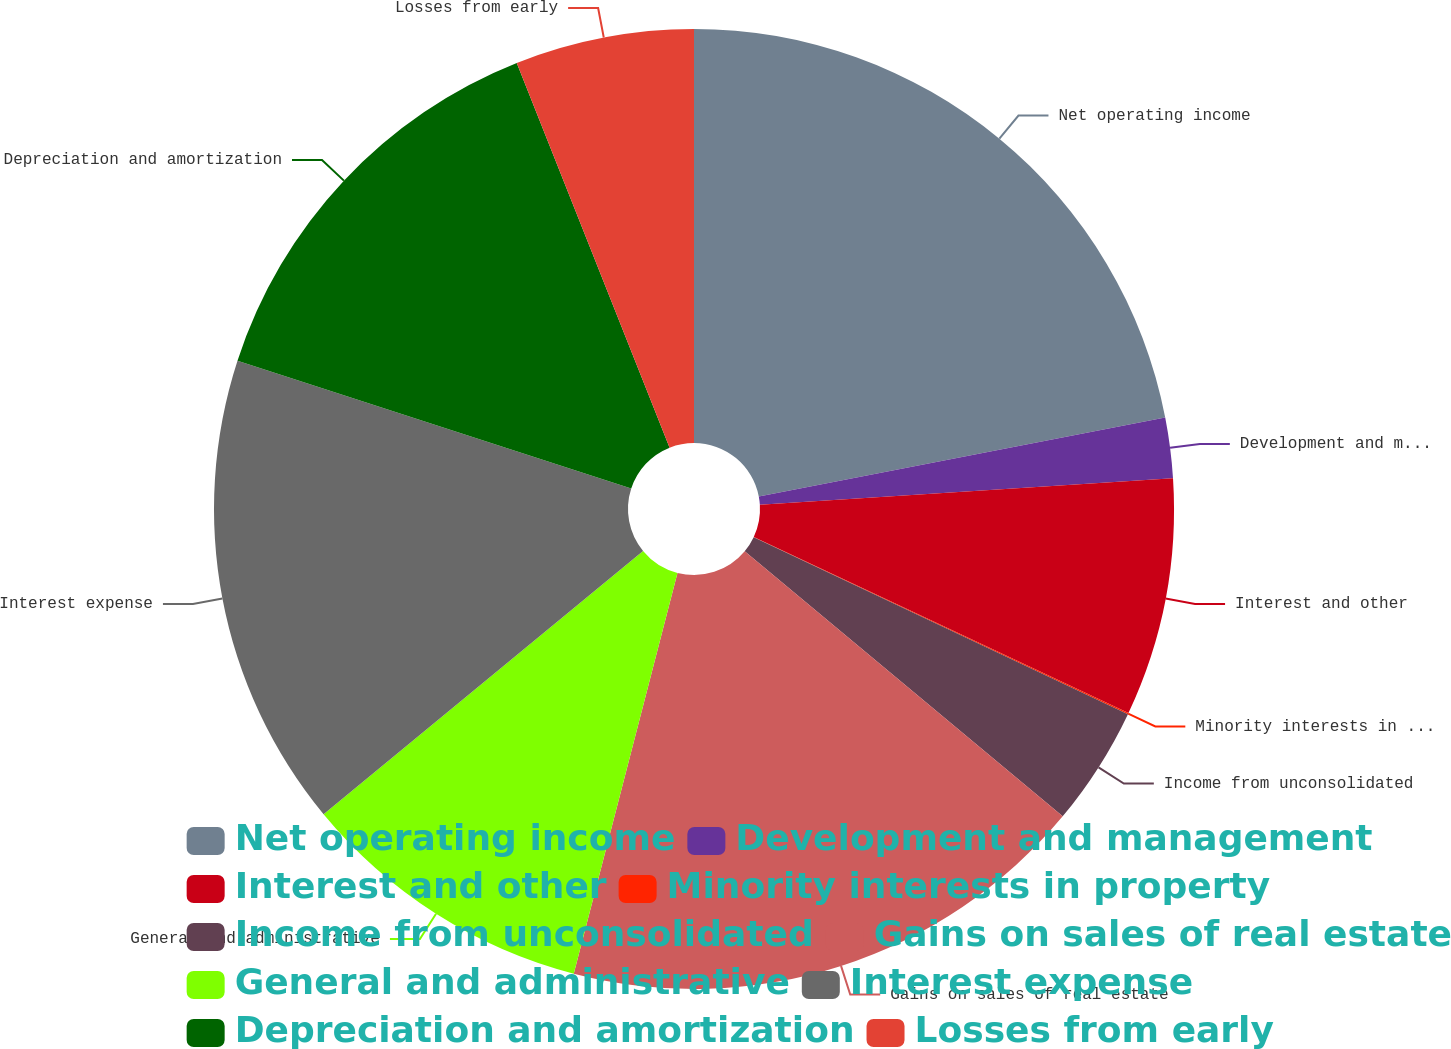Convert chart to OTSL. <chart><loc_0><loc_0><loc_500><loc_500><pie_chart><fcel>Net operating income<fcel>Development and management<fcel>Interest and other<fcel>Minority interests in property<fcel>Income from unconsolidated<fcel>Gains on sales of real estate<fcel>General and administrative<fcel>Interest expense<fcel>Depreciation and amortization<fcel>Losses from early<nl><fcel>21.95%<fcel>2.03%<fcel>8.01%<fcel>0.04%<fcel>4.03%<fcel>17.97%<fcel>10.0%<fcel>15.97%<fcel>13.98%<fcel>6.02%<nl></chart> 